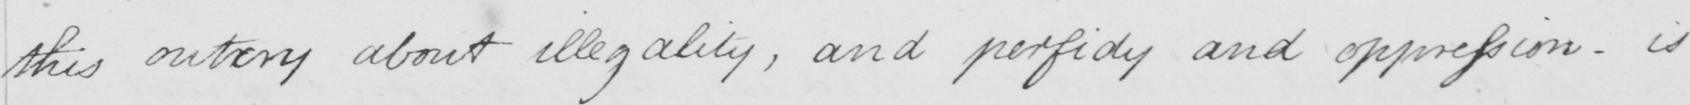Please transcribe the handwritten text in this image. this outcry about illegality , and perfidy and oppression - is 